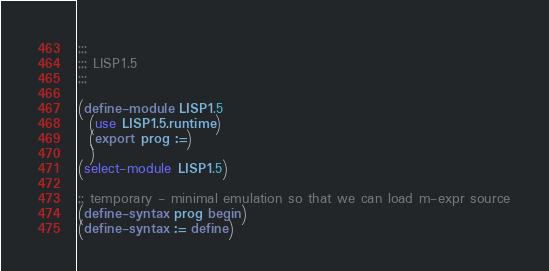<code> <loc_0><loc_0><loc_500><loc_500><_Scheme_>;;;
;;; LISP1.5
;;;

(define-module LISP1.5
  (use LISP1.5.runtime)
  (export prog :=)
  )
(select-module LISP1.5)

;; temporary - minimal emulation so that we can load m-expr source
(define-syntax prog begin)
(define-syntax := define)
</code> 